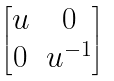Convert formula to latex. <formula><loc_0><loc_0><loc_500><loc_500>\begin{bmatrix} u & 0 \\ 0 & u ^ { - 1 } \end{bmatrix}</formula> 